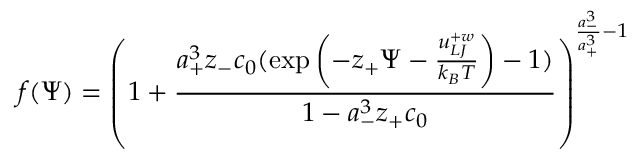Convert formula to latex. <formula><loc_0><loc_0><loc_500><loc_500>f ( \Psi ) = \left ( 1 + \frac { a _ { + } ^ { 3 } z _ { - } c _ { 0 } ( \exp \left ( - z _ { + } \Psi - \frac { u _ { L J } ^ { + w } } { k _ { B } T } \right ) - 1 ) } { 1 - a _ { - } ^ { 3 } z _ { + } c _ { 0 } } \right ) ^ { \frac { a _ { - } ^ { 3 } } { a _ { + } ^ { 3 } } - 1 }</formula> 